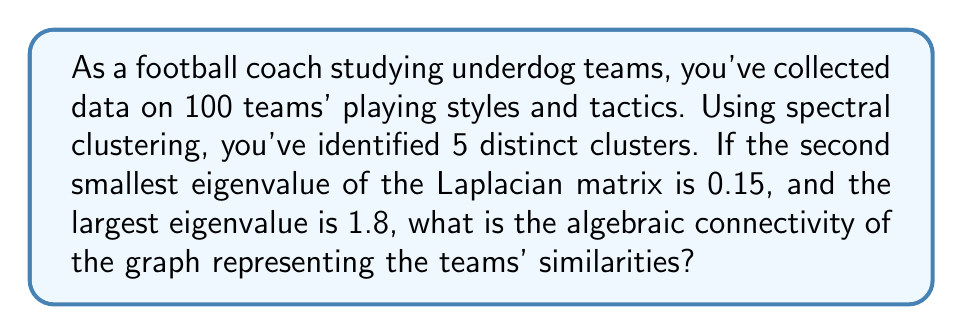What is the answer to this math problem? To solve this problem, we need to understand the concept of algebraic connectivity in spectral clustering:

1. In spectral clustering, we represent the similarities between teams as a graph, where each team is a node and the edges represent similarities in playing styles and tactics.

2. The Laplacian matrix $L$ of this graph is used to perform the clustering.

3. The eigenvalues of the Laplacian matrix provide important information about the graph structure.

4. The algebraic connectivity of a graph is defined as the second smallest eigenvalue of the Laplacian matrix. It's also known as the Fiedler value.

5. In this case, we're given that the second smallest eigenvalue is 0.15.

6. The algebraic connectivity is always non-negative and less than or equal to the number of vertices in the graph (in this case, 100).

7. A larger algebraic connectivity indicates a more connected graph, which would suggest that the teams' playing styles and tactics are more similar overall.

Therefore, the algebraic connectivity of the graph is simply the second smallest eigenvalue of the Laplacian matrix, which is 0.15.
Answer: 0.15 